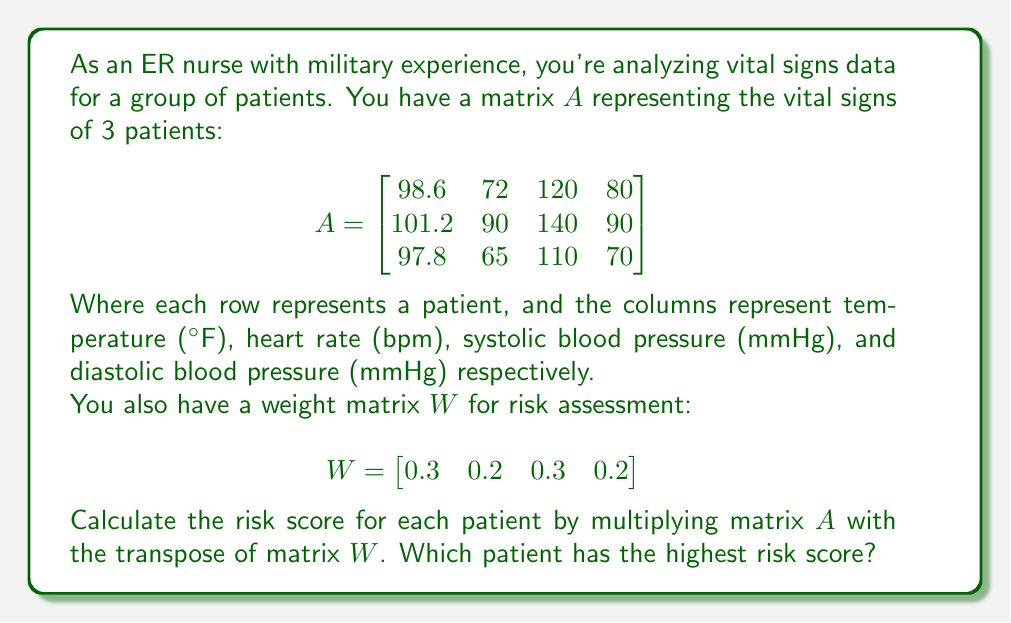Give your solution to this math problem. To solve this problem, we need to follow these steps:

1) First, we need to transpose matrix $W$. The transpose of $W$, denoted as $W^T$, is:

   $$W^T = \begin{bmatrix}
   0.3 \\
   0.2 \\
   0.3 \\
   0.2
   \end{bmatrix}$$

2) Now, we need to multiply matrix $A$ with $W^T$. The resulting matrix will have dimensions 3x1, where each element represents the risk score for a patient.

   $$AW^T = \begin{bmatrix}
   98.6 & 72 & 120 & 80 \\
   101.2 & 90 & 140 & 90 \\
   97.8 & 65 & 110 & 70
   \end{bmatrix} \times \begin{bmatrix}
   0.3 \\
   0.2 \\
   0.3 \\
   0.2
   \end{bmatrix}$$

3) Let's calculate this multiplication:

   For Patient 1: $(98.6 \times 0.3) + (72 \times 0.2) + (120 \times 0.3) + (80 \times 0.2) = 29.58 + 14.4 + 36 + 16 = 95.98$

   For Patient 2: $(101.2 \times 0.3) + (90 \times 0.2) + (140 \times 0.3) + (90 \times 0.2) = 30.36 + 18 + 42 + 18 = 108.36$

   For Patient 3: $(97.8 \times 0.3) + (65 \times 0.2) + (110 \times 0.3) + (70 \times 0.2) = 29.34 + 13 + 33 + 14 = 89.34$

4) The resulting risk score matrix is:

   $$AW^T = \begin{bmatrix}
   95.98 \\
   108.36 \\
   89.34
   \end{bmatrix}$$

5) Comparing these scores, we can see that Patient 2 has the highest risk score of 108.36.
Answer: Patient 2 has the highest risk score of 108.36. 